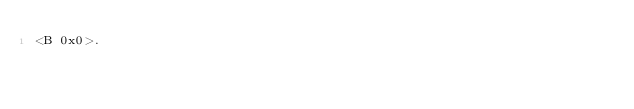Convert code to text. <code><loc_0><loc_0><loc_500><loc_500><_SML_><B 0x0>.
</code> 